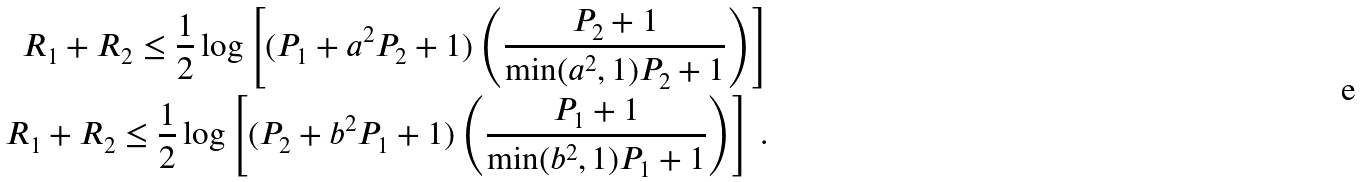<formula> <loc_0><loc_0><loc_500><loc_500>R _ { 1 } + R _ { 2 } \leq \frac { 1 } { 2 } \log \left [ ( P _ { 1 } + a ^ { 2 } P _ { 2 } + 1 ) \left ( \frac { P _ { 2 } + 1 } { \min ( a ^ { 2 } , 1 ) P _ { 2 } + 1 } \right ) \right ] \\ R _ { 1 } + R _ { 2 } \leq \frac { 1 } { 2 } \log \left [ ( P _ { 2 } + b ^ { 2 } P _ { 1 } + 1 ) \left ( \frac { P _ { 1 } + 1 } { \min ( b ^ { 2 } , 1 ) P _ { 1 } + 1 } \right ) \right ] \, .</formula> 